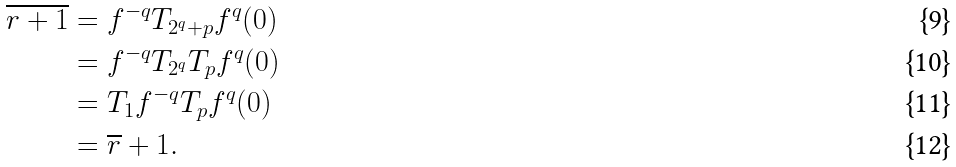Convert formula to latex. <formula><loc_0><loc_0><loc_500><loc_500>\overline { r + 1 } & = f ^ { - q } T _ { 2 ^ { q } + p } f ^ { q } ( 0 ) \\ & = f ^ { - q } T _ { 2 ^ { q } } T _ { p } f ^ { q } ( 0 ) \\ & = T _ { 1 } f ^ { - q } T _ { p } f ^ { q } ( 0 ) \\ & = \overline { r } + 1 .</formula> 